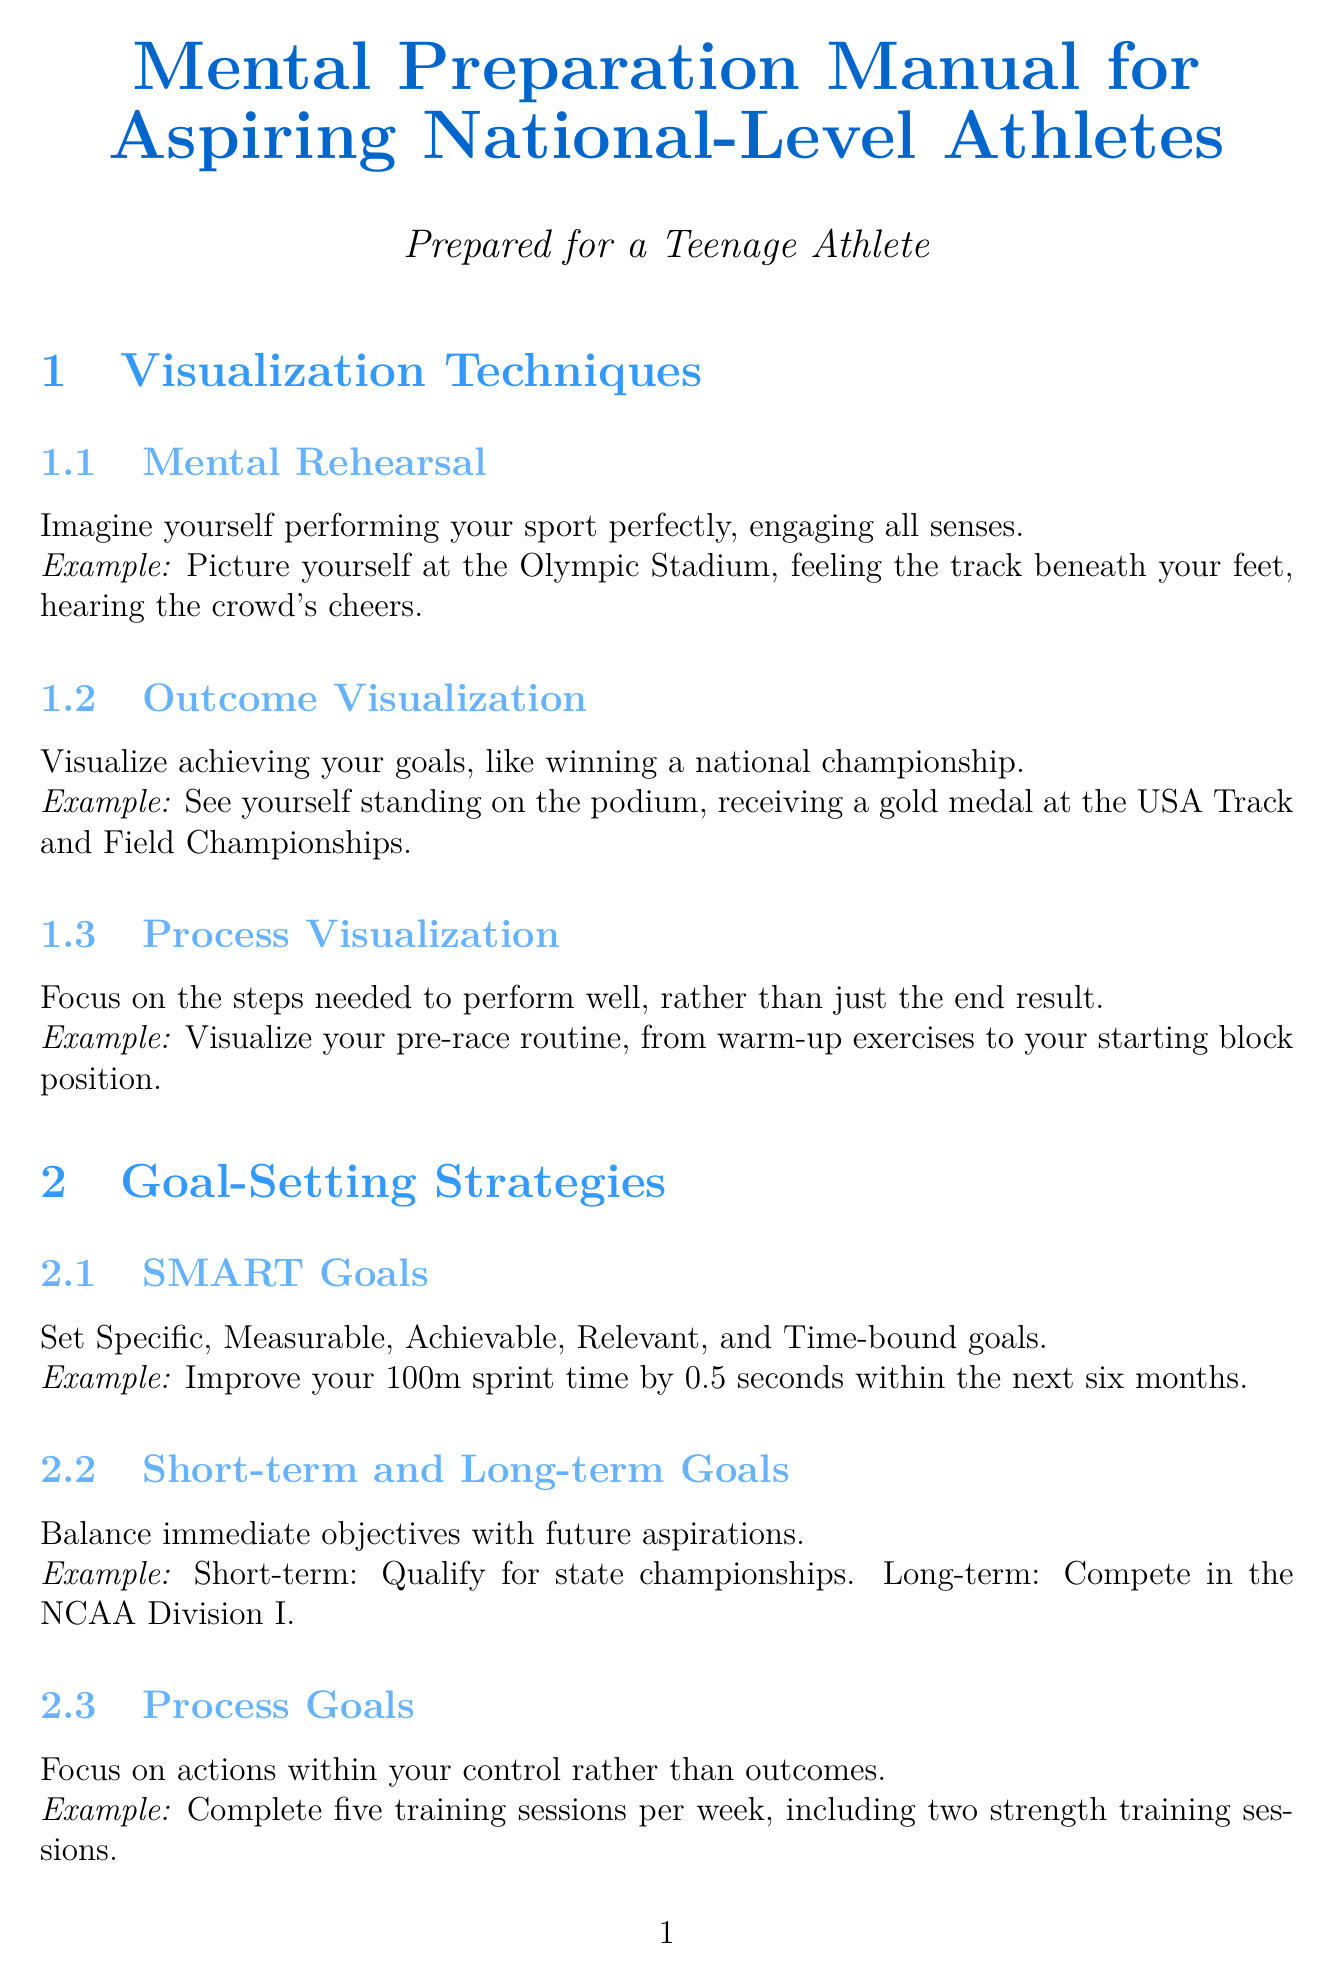What is the title of the manual? The title of the manual is stated at the beginning of the document.
Answer: Mental Preparation Manual for Aspiring National-Level Athletes How many visualization techniques are mentioned? The document lists the number of techniques in the section on Visualization Techniques.
Answer: 3 What is an example of process visualization? The document provides a specific example in the description of Process Visualization.
Answer: Visualize your pre-race routine, from warm-up exercises to your starting block position What does SMART stand for in goal-setting? The acronym is defined within the Goal-Setting Strategies section of the document.
Answer: Specific, Measurable, Achievable, Relevant, Time-bound What is a recommended hydration tip? A specific tip for hydration is given in the Nutrition for Mental Performance section.
Answer: Consult with your nutritionist mom about personalized hydration strategies for training and competition What is one way to improve sleep hygiene? The document lists several tips under the Sleep Hygiene aspect, focusing on improving sleep quality.
Answer: Aim for 8-10 hours of sleep per night What exercise is suggested for active recovery? The document provides examples of light exercises recommended on rest days.
Answer: Yoga What is a method for stress management mentioned? The document includes various strategies for managing stress in a specific section.
Answer: Positive Self-Talk 